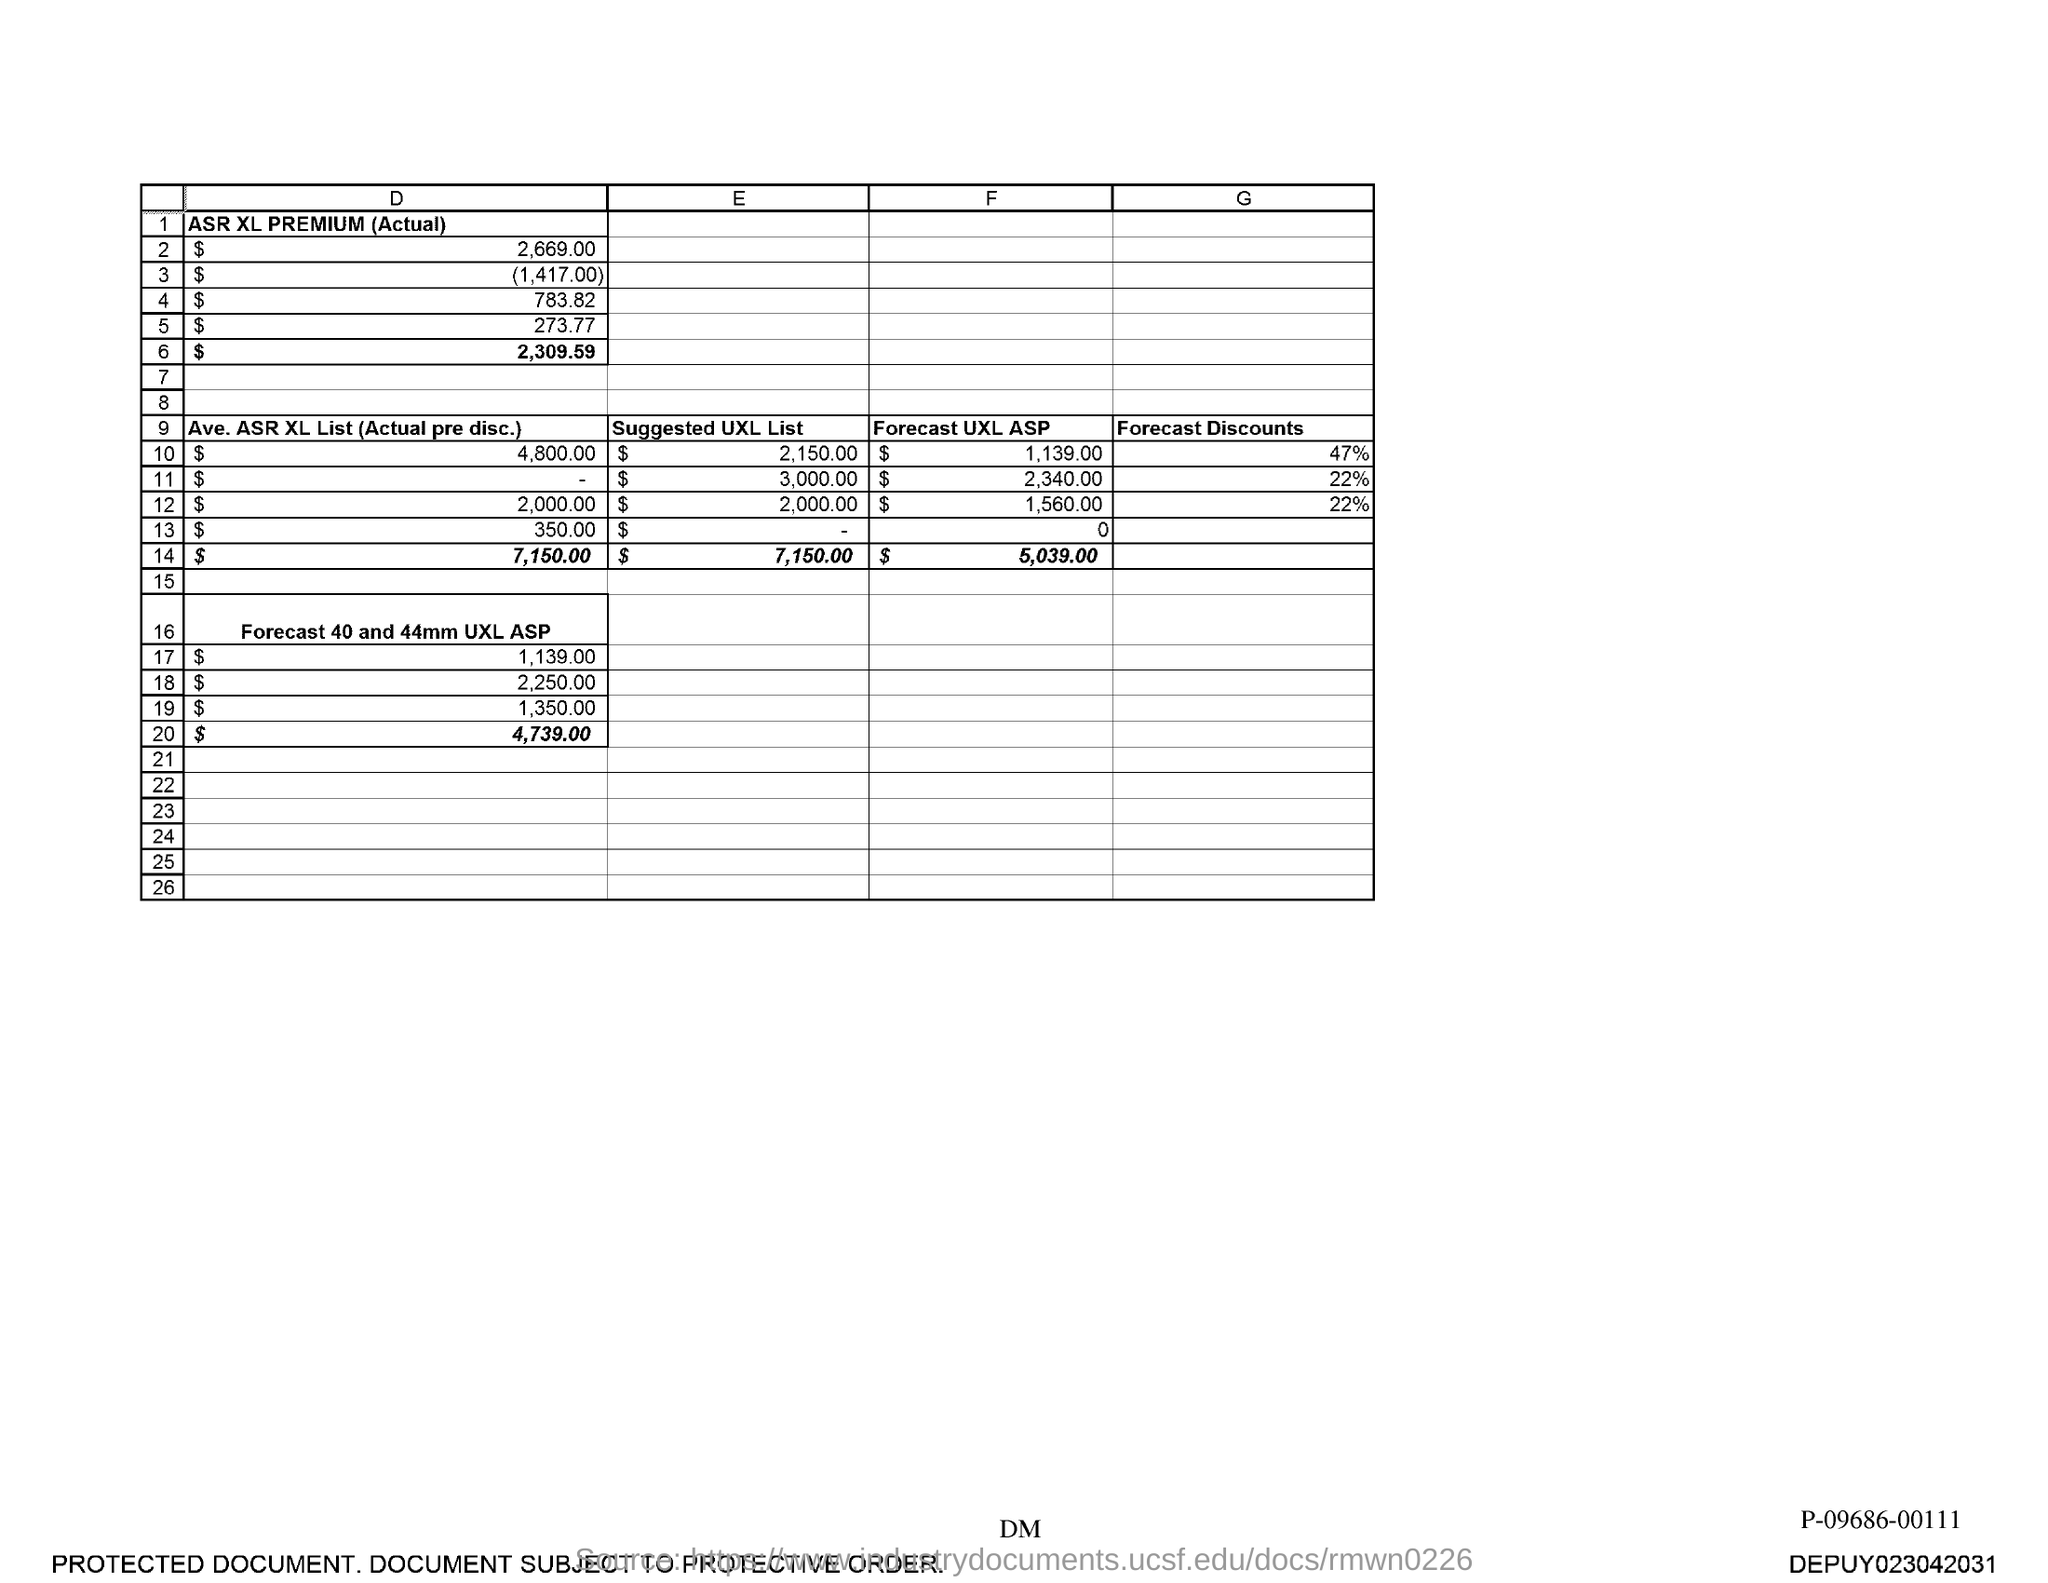What is the total of Suggested UXL List?
Keep it short and to the point. 7150. 